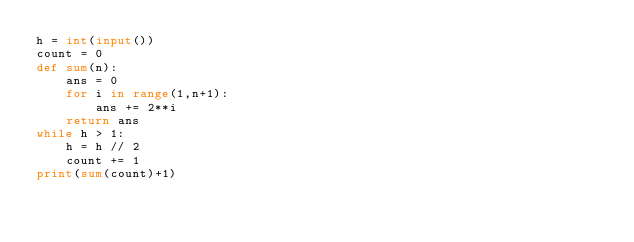Convert code to text. <code><loc_0><loc_0><loc_500><loc_500><_Python_>h = int(input())
count = 0
def sum(n):
    ans = 0
    for i in range(1,n+1):
        ans += 2**i
    return ans
while h > 1:
    h = h // 2
    count += 1
print(sum(count)+1)</code> 